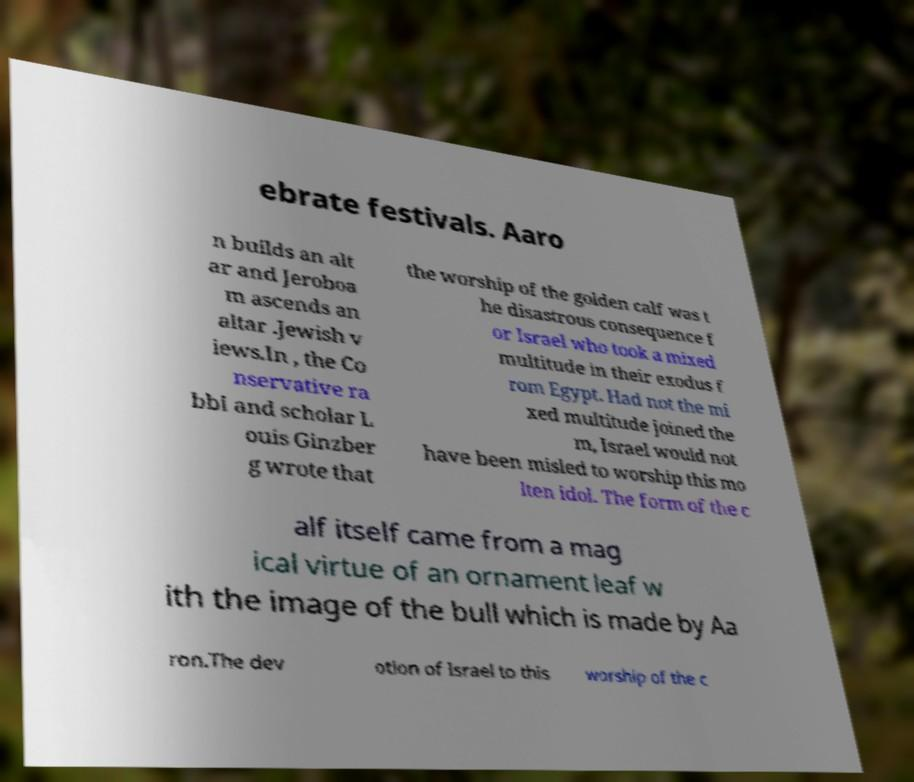I need the written content from this picture converted into text. Can you do that? ebrate festivals. Aaro n builds an alt ar and Jeroboa m ascends an altar .Jewish v iews.In , the Co nservative ra bbi and scholar L ouis Ginzber g wrote that the worship of the golden calf was t he disastrous consequence f or Israel who took a mixed multitude in their exodus f rom Egypt. Had not the mi xed multitude joined the m, Israel would not have been misled to worship this mo lten idol. The form of the c alf itself came from a mag ical virtue of an ornament leaf w ith the image of the bull which is made by Aa ron.The dev otion of Israel to this worship of the c 